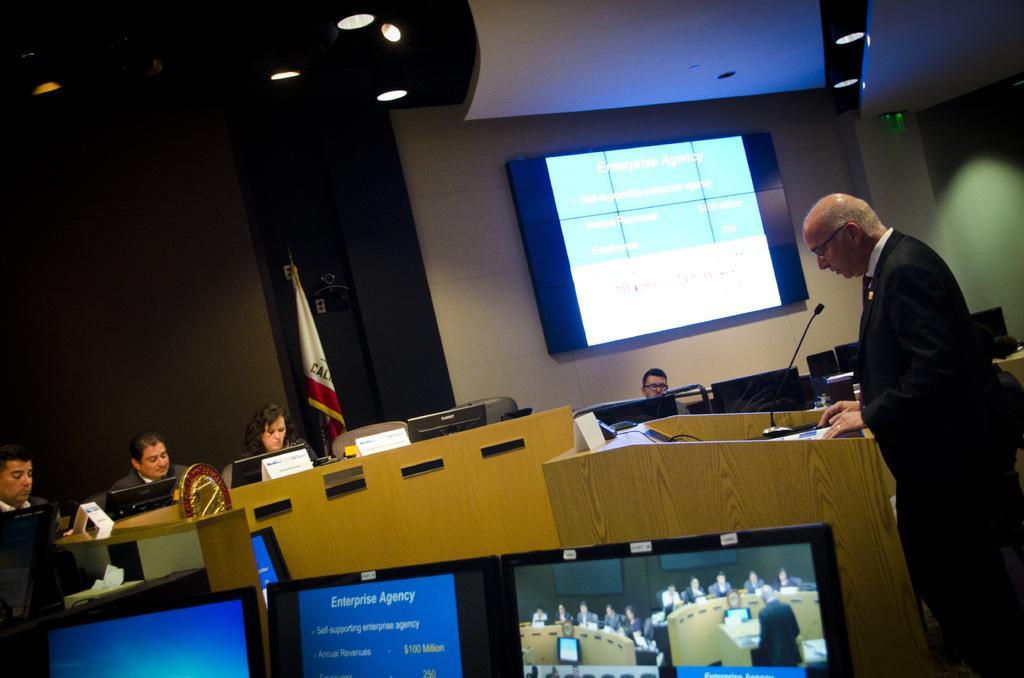How would you summarize this image in a sentence or two? In this image we can see monitors, podium, name boards, and a flag. There is a man standing in front of a mike and we can see four persons are sitting on the chairs. In the background we can see a screen, wall, and lights. 